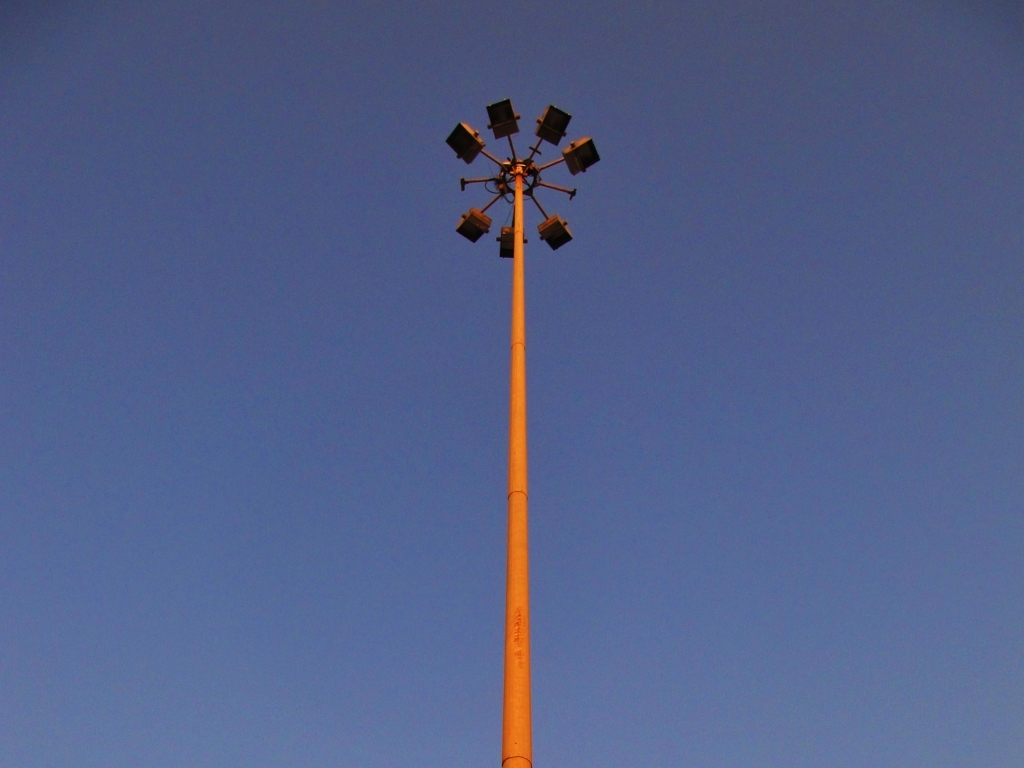Is there any distortion in the image?
 No 